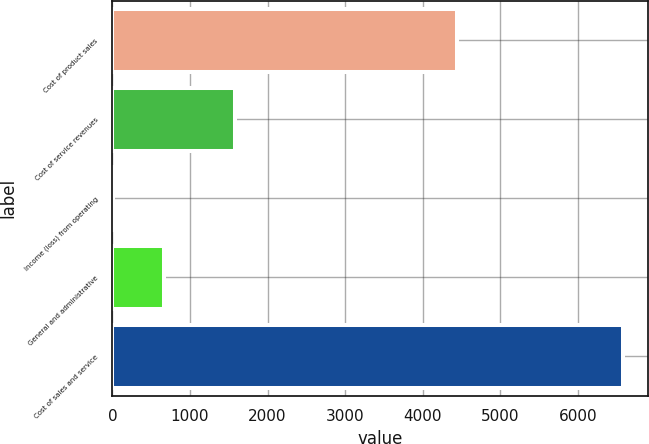Convert chart to OTSL. <chart><loc_0><loc_0><loc_500><loc_500><bar_chart><fcel>Cost of product sales<fcel>Cost of service revenues<fcel>Income (loss) from operating<fcel>General and administrative<fcel>Cost of sales and service<nl><fcel>4444<fcel>1574<fcel>12<fcel>668.4<fcel>6576<nl></chart> 